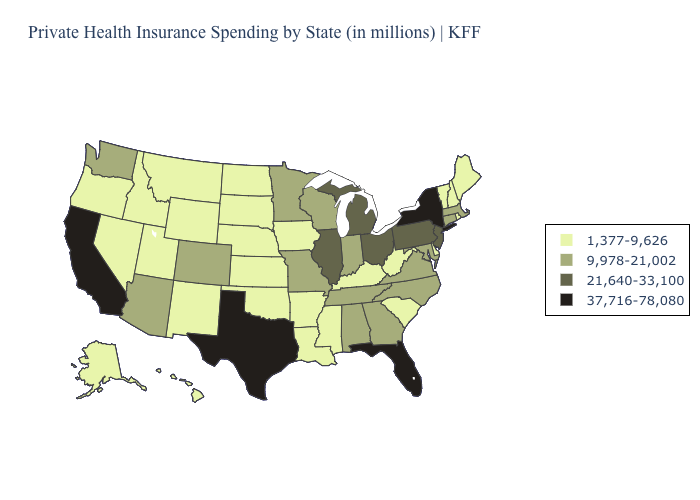Which states have the lowest value in the USA?
Be succinct. Alaska, Arkansas, Delaware, Hawaii, Idaho, Iowa, Kansas, Kentucky, Louisiana, Maine, Mississippi, Montana, Nebraska, Nevada, New Hampshire, New Mexico, North Dakota, Oklahoma, Oregon, Rhode Island, South Carolina, South Dakota, Utah, Vermont, West Virginia, Wyoming. Does Utah have the same value as Wyoming?
Quick response, please. Yes. What is the value of Kansas?
Keep it brief. 1,377-9,626. Name the states that have a value in the range 37,716-78,080?
Write a very short answer. California, Florida, New York, Texas. What is the lowest value in the West?
Write a very short answer. 1,377-9,626. Which states have the highest value in the USA?
Write a very short answer. California, Florida, New York, Texas. What is the value of Oklahoma?
Write a very short answer. 1,377-9,626. What is the lowest value in states that border Connecticut?
Concise answer only. 1,377-9,626. Does the map have missing data?
Give a very brief answer. No. Which states hav the highest value in the Northeast?
Quick response, please. New York. Which states have the highest value in the USA?
Answer briefly. California, Florida, New York, Texas. Does New Hampshire have a lower value than Utah?
Be succinct. No. What is the value of Vermont?
Write a very short answer. 1,377-9,626. What is the value of Tennessee?
Be succinct. 9,978-21,002. What is the highest value in the USA?
Keep it brief. 37,716-78,080. 